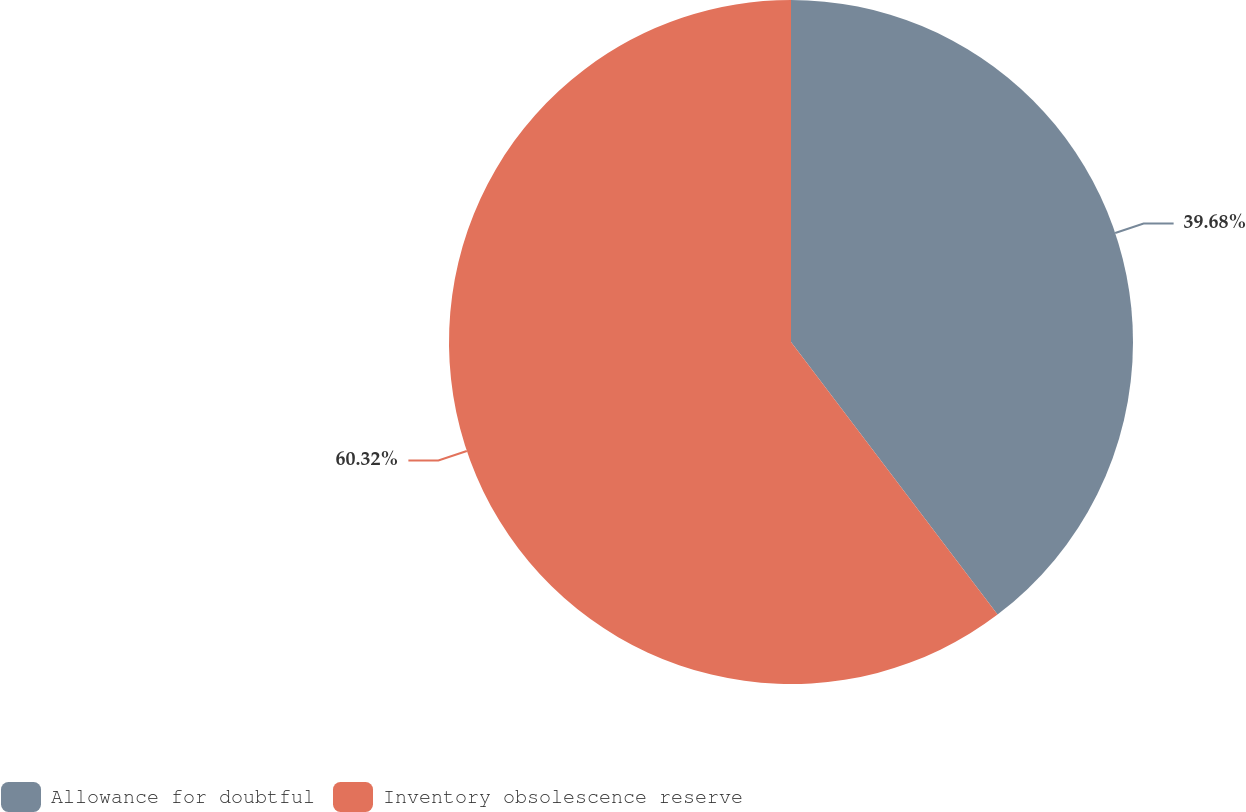<chart> <loc_0><loc_0><loc_500><loc_500><pie_chart><fcel>Allowance for doubtful<fcel>Inventory obsolescence reserve<nl><fcel>39.68%<fcel>60.32%<nl></chart> 